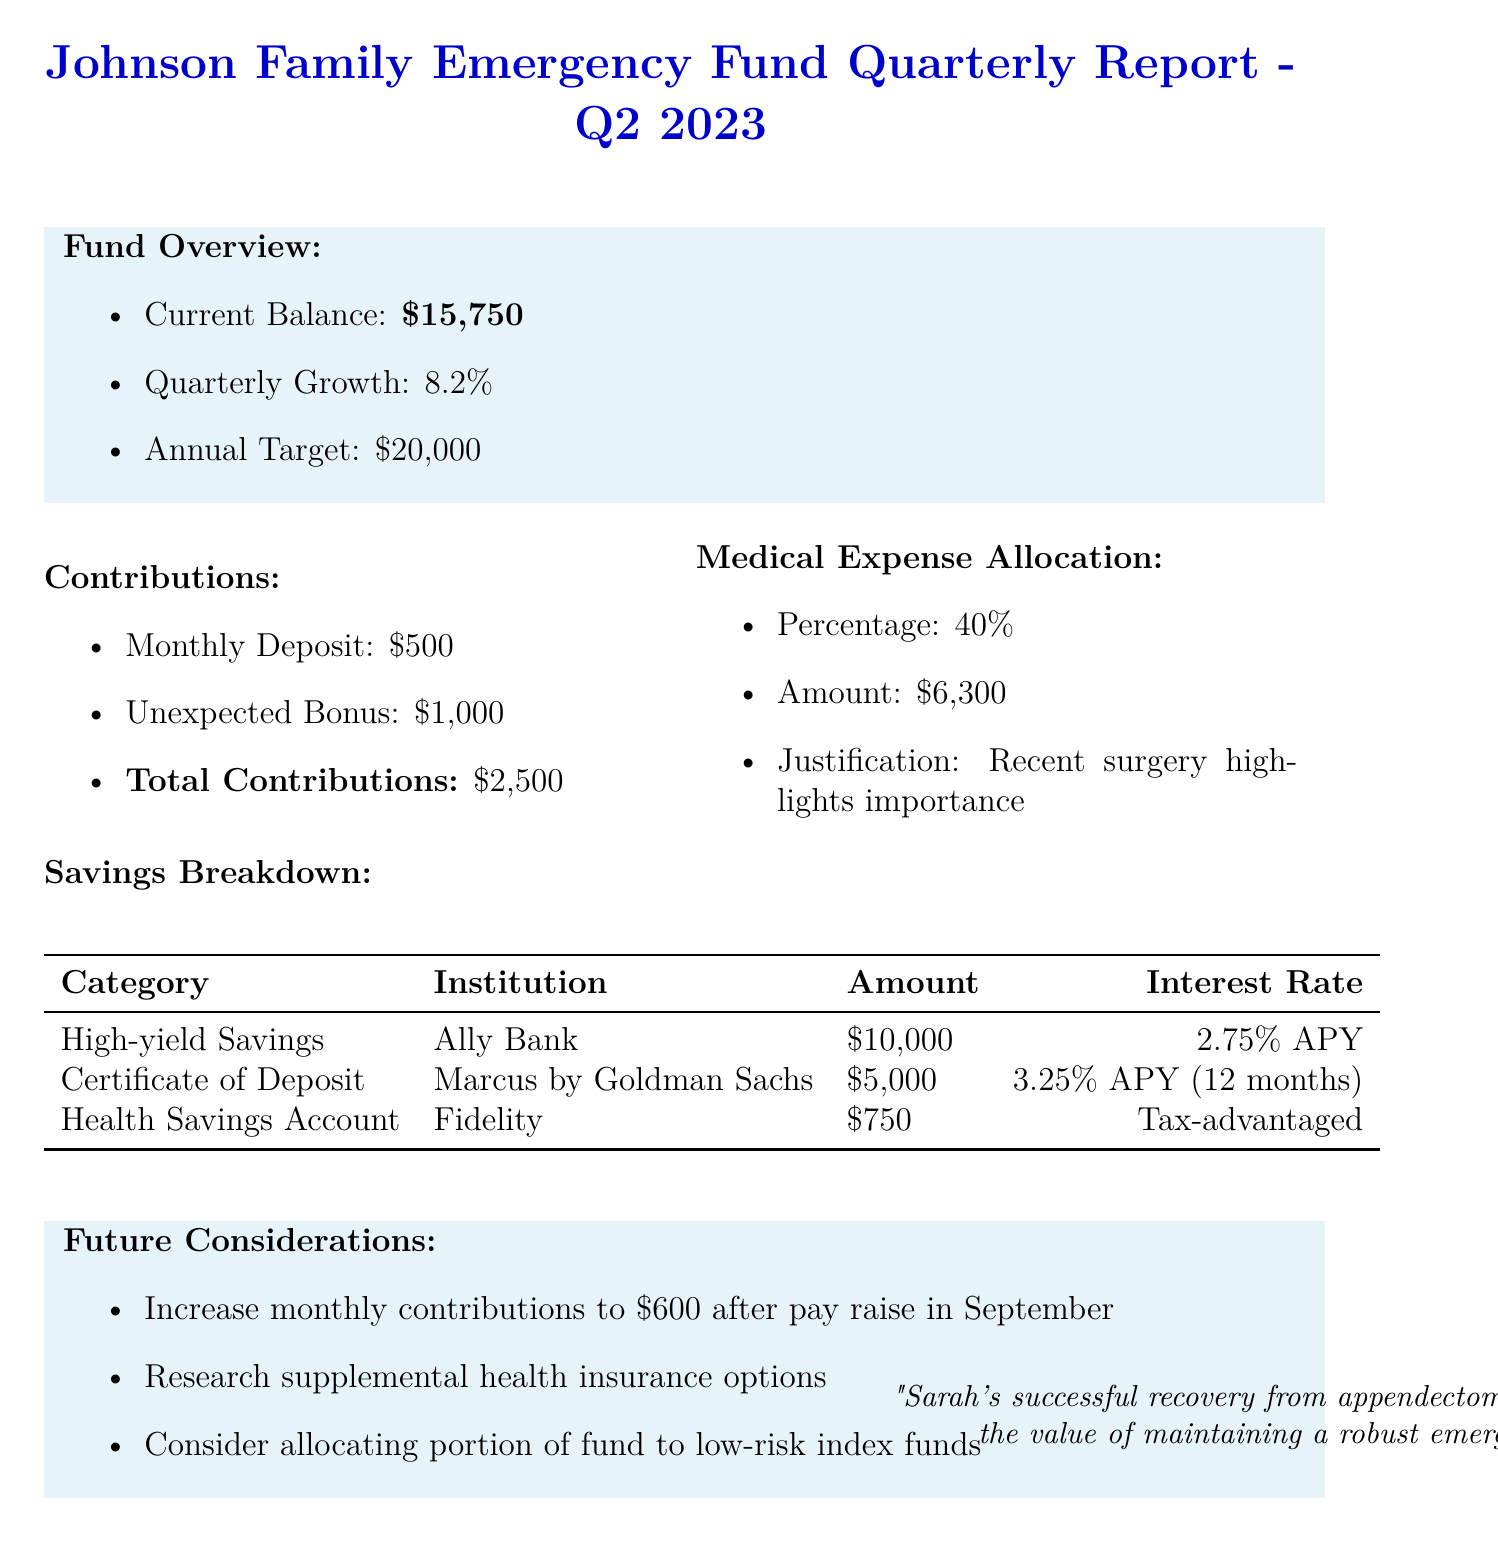What is the current balance of the emergency fund? The current balance is directly stated in the fund overview section of the document.
Answer: $15,750 What is the quarterly growth percentage? The quarterly growth percentage is provided in the fund overview section.
Answer: 8.2% What is the amount allocated for medical expenses? The specific amount allocated for medical expenses is listed in the medical expense allocation section.
Answer: $6,300 Which institution holds the high-yield savings account? The institution for the high-yield savings account is mentioned in the savings breakdown table.
Answer: Ally Bank What future consideration involves increasing monthly contributions? The document indicates a specific future consideration regarding contributions.
Answer: Increase monthly contributions to $600 What percentage of the emergency fund is allocated for medical expenses? The percentage is explicitly stated in the medical expense allocation section of the report.
Answer: 40% What is Sarah's recent health update related to? The health update mentions a specific event that reinforces the importance of the emergency fund.
Answer: Successful recovery from appendectomy Which savings account has the highest interest rate? The interest rates for different accounts are provided, enabling comparison.
Answer: Certificate of Deposit What is the annual target for the emergency fund? The target for the emergency fund is explicitly mentioned in the fund overview section.
Answer: $20,000 